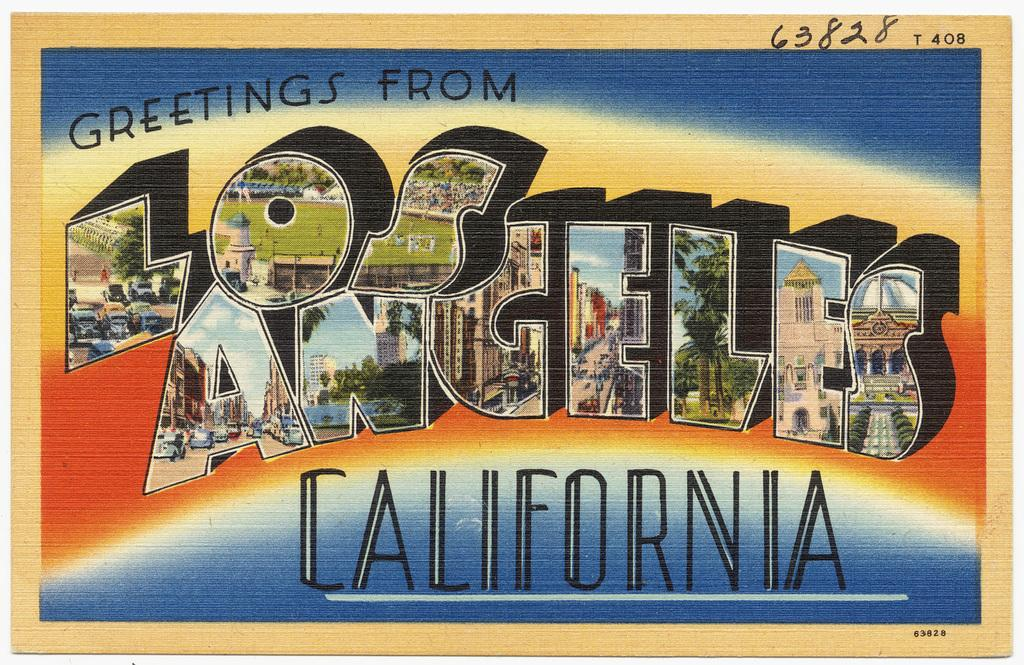<image>
Offer a succinct explanation of the picture presented. A postcard that says Greetings from Los Angeles California. 